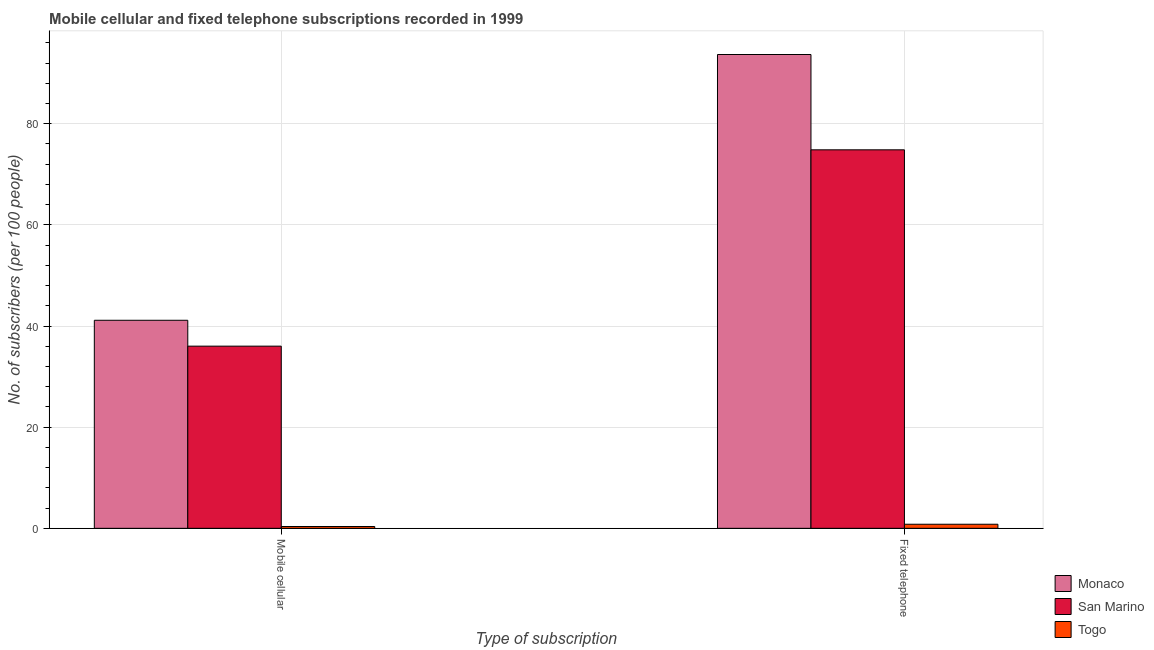How many bars are there on the 1st tick from the right?
Provide a short and direct response. 3. What is the label of the 2nd group of bars from the left?
Provide a succinct answer. Fixed telephone. What is the number of fixed telephone subscribers in San Marino?
Make the answer very short. 74.84. Across all countries, what is the maximum number of fixed telephone subscribers?
Give a very brief answer. 93.69. Across all countries, what is the minimum number of fixed telephone subscribers?
Make the answer very short. 0.81. In which country was the number of mobile cellular subscribers maximum?
Provide a short and direct response. Monaco. In which country was the number of mobile cellular subscribers minimum?
Provide a short and direct response. Togo. What is the total number of mobile cellular subscribers in the graph?
Provide a short and direct response. 77.52. What is the difference between the number of mobile cellular subscribers in Monaco and that in San Marino?
Ensure brevity in your answer.  5.12. What is the difference between the number of mobile cellular subscribers in San Marino and the number of fixed telephone subscribers in Togo?
Ensure brevity in your answer.  35.22. What is the average number of mobile cellular subscribers per country?
Offer a terse response. 25.84. What is the difference between the number of mobile cellular subscribers and number of fixed telephone subscribers in San Marino?
Provide a short and direct response. -38.82. What is the ratio of the number of mobile cellular subscribers in Monaco to that in Togo?
Your answer should be compact. 114.73. What does the 1st bar from the left in Fixed telephone represents?
Keep it short and to the point. Monaco. What does the 3rd bar from the right in Mobile cellular represents?
Give a very brief answer. Monaco. How many bars are there?
Provide a succinct answer. 6. How many countries are there in the graph?
Offer a very short reply. 3. Are the values on the major ticks of Y-axis written in scientific E-notation?
Offer a very short reply. No. What is the title of the graph?
Offer a terse response. Mobile cellular and fixed telephone subscriptions recorded in 1999. Does "Angola" appear as one of the legend labels in the graph?
Your answer should be compact. No. What is the label or title of the X-axis?
Your response must be concise. Type of subscription. What is the label or title of the Y-axis?
Give a very brief answer. No. of subscribers (per 100 people). What is the No. of subscribers (per 100 people) in Monaco in Mobile cellular?
Give a very brief answer. 41.14. What is the No. of subscribers (per 100 people) of San Marino in Mobile cellular?
Offer a terse response. 36.02. What is the No. of subscribers (per 100 people) in Togo in Mobile cellular?
Keep it short and to the point. 0.36. What is the No. of subscribers (per 100 people) of Monaco in Fixed telephone?
Give a very brief answer. 93.69. What is the No. of subscribers (per 100 people) in San Marino in Fixed telephone?
Make the answer very short. 74.84. What is the No. of subscribers (per 100 people) of Togo in Fixed telephone?
Provide a short and direct response. 0.81. Across all Type of subscription, what is the maximum No. of subscribers (per 100 people) of Monaco?
Provide a short and direct response. 93.69. Across all Type of subscription, what is the maximum No. of subscribers (per 100 people) in San Marino?
Keep it short and to the point. 74.84. Across all Type of subscription, what is the maximum No. of subscribers (per 100 people) of Togo?
Provide a succinct answer. 0.81. Across all Type of subscription, what is the minimum No. of subscribers (per 100 people) in Monaco?
Keep it short and to the point. 41.14. Across all Type of subscription, what is the minimum No. of subscribers (per 100 people) in San Marino?
Provide a succinct answer. 36.02. Across all Type of subscription, what is the minimum No. of subscribers (per 100 people) of Togo?
Provide a succinct answer. 0.36. What is the total No. of subscribers (per 100 people) in Monaco in the graph?
Your response must be concise. 134.83. What is the total No. of subscribers (per 100 people) in San Marino in the graph?
Give a very brief answer. 110.87. What is the total No. of subscribers (per 100 people) of Togo in the graph?
Your response must be concise. 1.16. What is the difference between the No. of subscribers (per 100 people) of Monaco in Mobile cellular and that in Fixed telephone?
Provide a short and direct response. -52.55. What is the difference between the No. of subscribers (per 100 people) in San Marino in Mobile cellular and that in Fixed telephone?
Offer a terse response. -38.82. What is the difference between the No. of subscribers (per 100 people) in Togo in Mobile cellular and that in Fixed telephone?
Your answer should be compact. -0.45. What is the difference between the No. of subscribers (per 100 people) of Monaco in Mobile cellular and the No. of subscribers (per 100 people) of San Marino in Fixed telephone?
Keep it short and to the point. -33.71. What is the difference between the No. of subscribers (per 100 people) of Monaco in Mobile cellular and the No. of subscribers (per 100 people) of Togo in Fixed telephone?
Make the answer very short. 40.33. What is the difference between the No. of subscribers (per 100 people) of San Marino in Mobile cellular and the No. of subscribers (per 100 people) of Togo in Fixed telephone?
Your answer should be very brief. 35.22. What is the average No. of subscribers (per 100 people) in Monaco per Type of subscription?
Keep it short and to the point. 67.41. What is the average No. of subscribers (per 100 people) of San Marino per Type of subscription?
Provide a short and direct response. 55.43. What is the average No. of subscribers (per 100 people) of Togo per Type of subscription?
Give a very brief answer. 0.58. What is the difference between the No. of subscribers (per 100 people) of Monaco and No. of subscribers (per 100 people) of San Marino in Mobile cellular?
Ensure brevity in your answer.  5.12. What is the difference between the No. of subscribers (per 100 people) in Monaco and No. of subscribers (per 100 people) in Togo in Mobile cellular?
Provide a short and direct response. 40.78. What is the difference between the No. of subscribers (per 100 people) in San Marino and No. of subscribers (per 100 people) in Togo in Mobile cellular?
Your response must be concise. 35.66. What is the difference between the No. of subscribers (per 100 people) of Monaco and No. of subscribers (per 100 people) of San Marino in Fixed telephone?
Provide a succinct answer. 18.85. What is the difference between the No. of subscribers (per 100 people) of Monaco and No. of subscribers (per 100 people) of Togo in Fixed telephone?
Keep it short and to the point. 92.89. What is the difference between the No. of subscribers (per 100 people) of San Marino and No. of subscribers (per 100 people) of Togo in Fixed telephone?
Make the answer very short. 74.04. What is the ratio of the No. of subscribers (per 100 people) in Monaco in Mobile cellular to that in Fixed telephone?
Ensure brevity in your answer.  0.44. What is the ratio of the No. of subscribers (per 100 people) of San Marino in Mobile cellular to that in Fixed telephone?
Offer a very short reply. 0.48. What is the ratio of the No. of subscribers (per 100 people) in Togo in Mobile cellular to that in Fixed telephone?
Your answer should be very brief. 0.45. What is the difference between the highest and the second highest No. of subscribers (per 100 people) of Monaco?
Ensure brevity in your answer.  52.55. What is the difference between the highest and the second highest No. of subscribers (per 100 people) of San Marino?
Provide a succinct answer. 38.82. What is the difference between the highest and the second highest No. of subscribers (per 100 people) of Togo?
Your answer should be very brief. 0.45. What is the difference between the highest and the lowest No. of subscribers (per 100 people) in Monaco?
Offer a very short reply. 52.55. What is the difference between the highest and the lowest No. of subscribers (per 100 people) in San Marino?
Keep it short and to the point. 38.82. What is the difference between the highest and the lowest No. of subscribers (per 100 people) in Togo?
Ensure brevity in your answer.  0.45. 